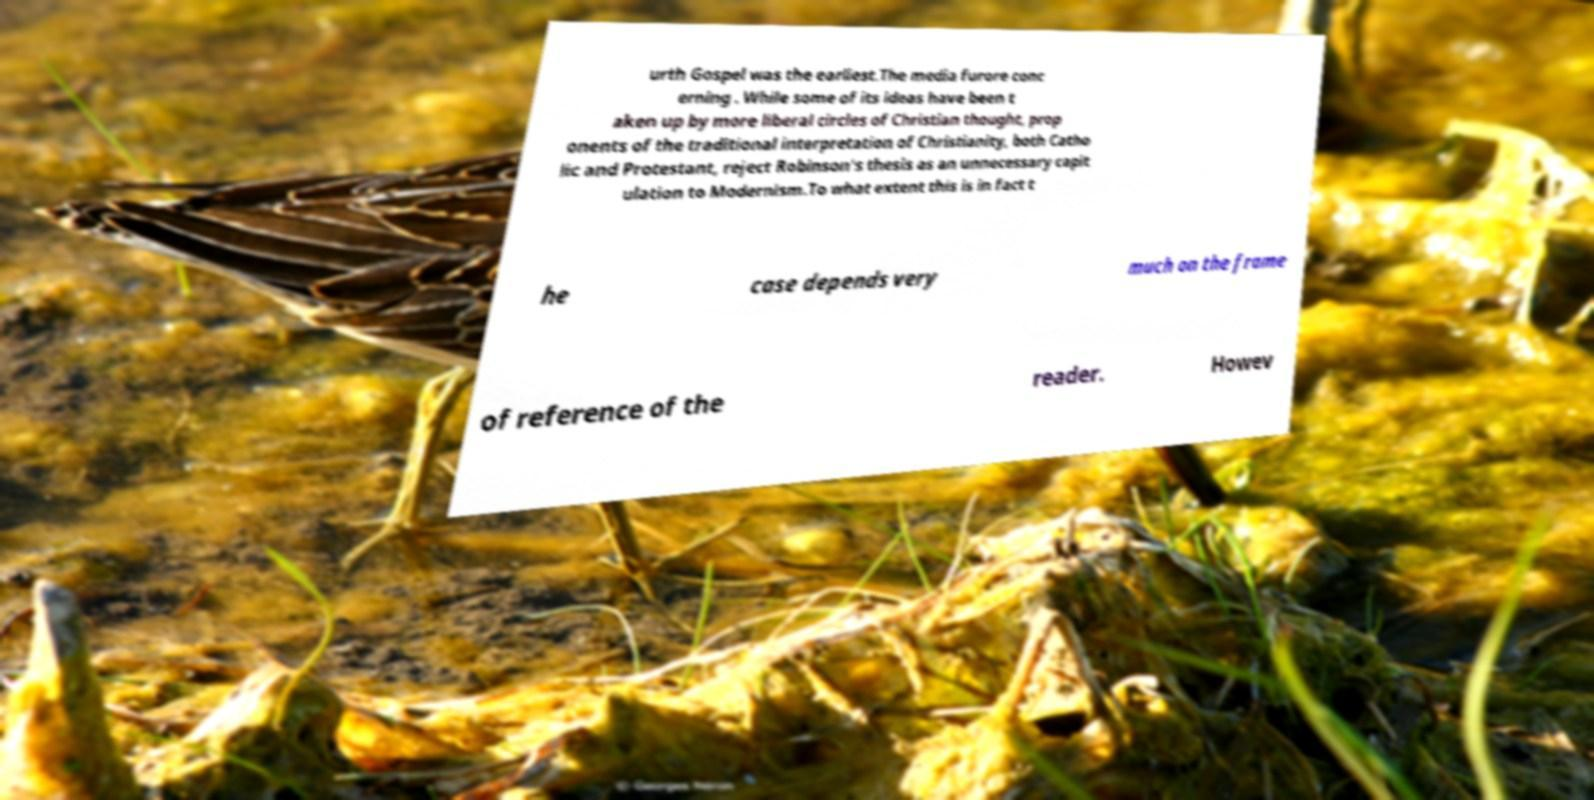Could you assist in decoding the text presented in this image and type it out clearly? urth Gospel was the earliest.The media furore conc erning . While some of its ideas have been t aken up by more liberal circles of Christian thought, prop onents of the traditional interpretation of Christianity, both Catho lic and Protestant, reject Robinson's thesis as an unnecessary capit ulation to Modernism.To what extent this is in fact t he case depends very much on the frame of reference of the reader. Howev 